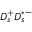Convert formula to latex. <formula><loc_0><loc_0><loc_500><loc_500>D _ { s } ^ { + } D _ { s } ^ { * - }</formula> 